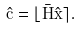<formula> <loc_0><loc_0><loc_500><loc_500>\hat { \mathbf c } = \lfloor { \bar { \mathbf H } \hat { \mathbf x } } \rceil .</formula> 